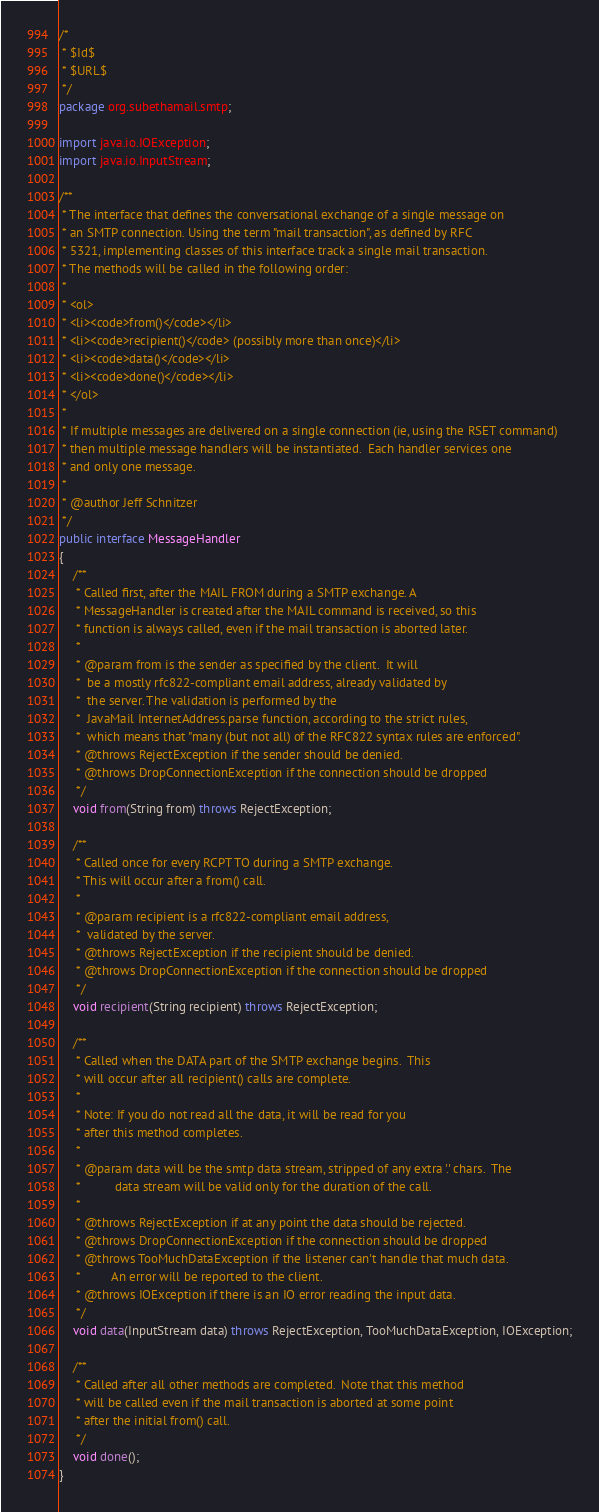Convert code to text. <code><loc_0><loc_0><loc_500><loc_500><_Java_>/*
 * $Id$
 * $URL$
 */
package org.subethamail.smtp;

import java.io.IOException;
import java.io.InputStream;

/**
 * The interface that defines the conversational exchange of a single message on
 * an SMTP connection. Using the term "mail transaction", as defined by RFC 
 * 5321, implementing classes of this interface track a single mail transaction. 
 * The methods will be called in the following order:
 *
 * <ol>
 * <li><code>from()</code></li>
 * <li><code>recipient()</code> (possibly more than once)</li>
 * <li><code>data()</code></li>
 * <li><code>done()</code></li>
 * </ol>
 *
 * If multiple messages are delivered on a single connection (ie, using the RSET command)
 * then multiple message handlers will be instantiated.  Each handler services one
 * and only one message.
 *
 * @author Jeff Schnitzer
 */
public interface MessageHandler
{
	/**
	 * Called first, after the MAIL FROM during a SMTP exchange. A 
	 * MessageHandler is created after the MAIL command is received, so this 
	 * function is always called, even if the mail transaction is aborted later.
	 *
	 * @param from is the sender as specified by the client.  It will
	 *  be a mostly rfc822-compliant email address, already validated by
	 *  the server. The validation is performed by the 
	 *  JavaMail InternetAddress.parse function, according to the strict rules,
	 *  which means that "many (but not all) of the RFC822 syntax rules are enforced".
	 * @throws RejectException if the sender should be denied.
	 * @throws DropConnectionException if the connection should be dropped
	 */
	void from(String from) throws RejectException;

	/**
	 * Called once for every RCPT TO during a SMTP exchange.
	 * This will occur after a from() call.
	 *
	 * @param recipient is a rfc822-compliant email address,
	 *  validated by the server.
	 * @throws RejectException if the recipient should be denied.
	 * @throws DropConnectionException if the connection should be dropped
	 */
	void recipient(String recipient) throws RejectException;

	/**
	 * Called when the DATA part of the SMTP exchange begins.  This
	 * will occur after all recipient() calls are complete.
	 *
	 * Note: If you do not read all the data, it will be read for you
	 * after this method completes.
	 *
	 * @param data will be the smtp data stream, stripped of any extra '.' chars.  The
	 * 			data stream will be valid only for the duration of the call.
	 *
	 * @throws RejectException if at any point the data should be rejected.
	 * @throws DropConnectionException if the connection should be dropped
	 * @throws TooMuchDataException if the listener can't handle that much data.
	 *         An error will be reported to the client.
	 * @throws IOException if there is an IO error reading the input data.
	 */
	void data(InputStream data) throws RejectException, TooMuchDataException, IOException;

	/**
	 * Called after all other methods are completed.  Note that this method
	 * will be called even if the mail transaction is aborted at some point 
	 * after the initial from() call. 
	 */
	void done();
}
</code> 